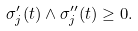Convert formula to latex. <formula><loc_0><loc_0><loc_500><loc_500>\sigma _ { j } ^ { \prime } ( t ) \land \sigma _ { j } ^ { \prime \prime } ( t ) \geq 0 .</formula> 